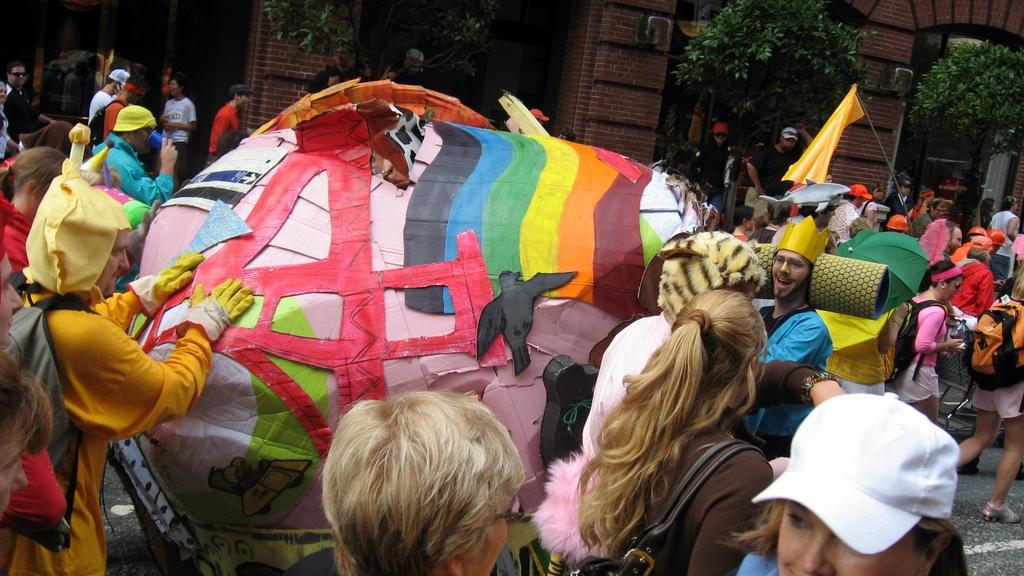What is happening in the middle of the image? There are people standing in the middle of the image. What are the people holding in their hands? The people are holding something in their hands. What can be seen in the background of the image? There are trees and buildings visible in the background. What type of metal is visible on the tail of the animal in the image? There is no animal or metal present in the image. 